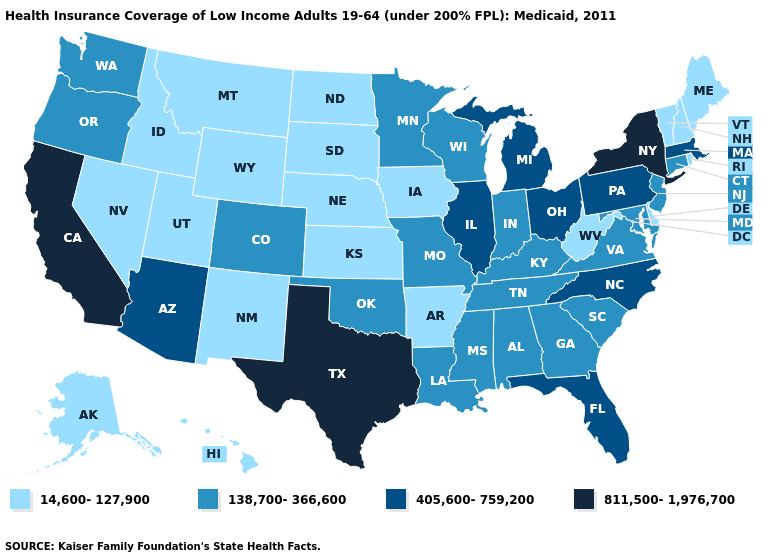Name the states that have a value in the range 405,600-759,200?
Keep it brief. Arizona, Florida, Illinois, Massachusetts, Michigan, North Carolina, Ohio, Pennsylvania. What is the value of Colorado?
Short answer required. 138,700-366,600. Which states have the lowest value in the MidWest?
Keep it brief. Iowa, Kansas, Nebraska, North Dakota, South Dakota. What is the value of Indiana?
Be succinct. 138,700-366,600. Does North Dakota have the highest value in the USA?
Be succinct. No. Name the states that have a value in the range 14,600-127,900?
Quick response, please. Alaska, Arkansas, Delaware, Hawaii, Idaho, Iowa, Kansas, Maine, Montana, Nebraska, Nevada, New Hampshire, New Mexico, North Dakota, Rhode Island, South Dakota, Utah, Vermont, West Virginia, Wyoming. How many symbols are there in the legend?
Be succinct. 4. Name the states that have a value in the range 138,700-366,600?
Short answer required. Alabama, Colorado, Connecticut, Georgia, Indiana, Kentucky, Louisiana, Maryland, Minnesota, Mississippi, Missouri, New Jersey, Oklahoma, Oregon, South Carolina, Tennessee, Virginia, Washington, Wisconsin. What is the value of Oklahoma?
Quick response, please. 138,700-366,600. Does Minnesota have a lower value than Texas?
Keep it brief. Yes. What is the lowest value in the MidWest?
Be succinct. 14,600-127,900. Does the first symbol in the legend represent the smallest category?
Keep it brief. Yes. Does South Carolina have the highest value in the USA?
Short answer required. No. What is the value of Indiana?
Answer briefly. 138,700-366,600. Name the states that have a value in the range 14,600-127,900?
Concise answer only. Alaska, Arkansas, Delaware, Hawaii, Idaho, Iowa, Kansas, Maine, Montana, Nebraska, Nevada, New Hampshire, New Mexico, North Dakota, Rhode Island, South Dakota, Utah, Vermont, West Virginia, Wyoming. 